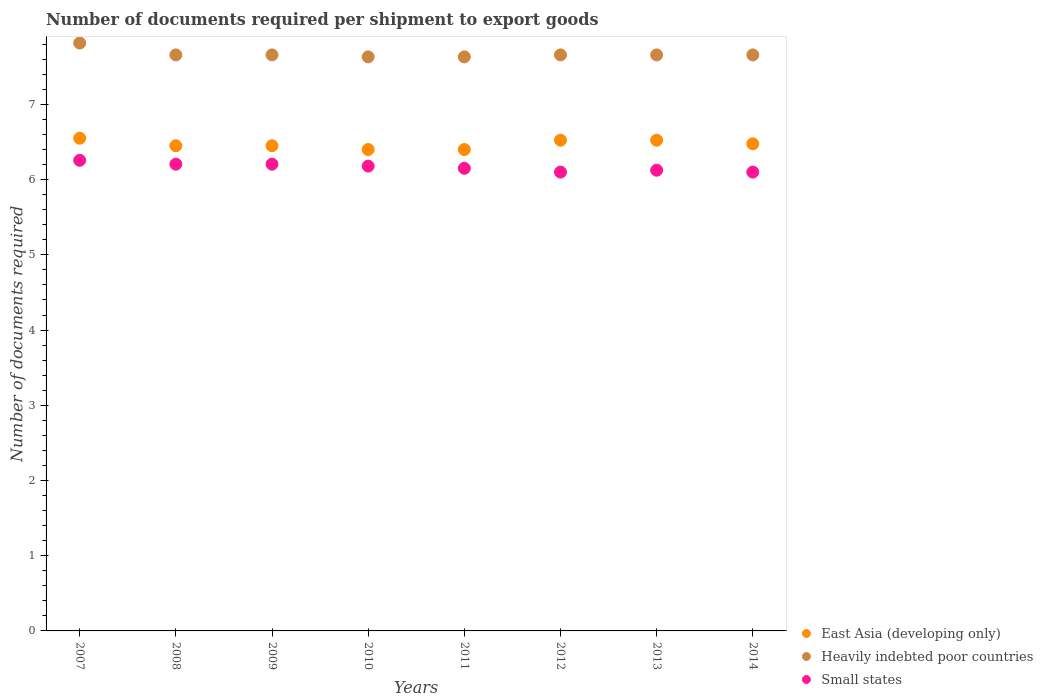What is the number of documents required per shipment to export goods in Heavily indebted poor countries in 2013?
Ensure brevity in your answer.  7.66. Across all years, what is the maximum number of documents required per shipment to export goods in Heavily indebted poor countries?
Ensure brevity in your answer.  7.82. Across all years, what is the minimum number of documents required per shipment to export goods in Small states?
Keep it short and to the point. 6.1. In which year was the number of documents required per shipment to export goods in Heavily indebted poor countries maximum?
Ensure brevity in your answer.  2007. What is the total number of documents required per shipment to export goods in Small states in the graph?
Provide a succinct answer. 49.32. What is the difference between the number of documents required per shipment to export goods in East Asia (developing only) in 2007 and that in 2009?
Give a very brief answer. 0.1. What is the difference between the number of documents required per shipment to export goods in Small states in 2011 and the number of documents required per shipment to export goods in Heavily indebted poor countries in 2014?
Keep it short and to the point. -1.51. What is the average number of documents required per shipment to export goods in Heavily indebted poor countries per year?
Give a very brief answer. 7.67. In the year 2014, what is the difference between the number of documents required per shipment to export goods in Small states and number of documents required per shipment to export goods in East Asia (developing only)?
Make the answer very short. -0.38. What is the ratio of the number of documents required per shipment to export goods in East Asia (developing only) in 2010 to that in 2012?
Give a very brief answer. 0.98. Is the number of documents required per shipment to export goods in Small states in 2007 less than that in 2009?
Provide a succinct answer. No. Is the difference between the number of documents required per shipment to export goods in Small states in 2007 and 2013 greater than the difference between the number of documents required per shipment to export goods in East Asia (developing only) in 2007 and 2013?
Offer a terse response. Yes. What is the difference between the highest and the second highest number of documents required per shipment to export goods in Small states?
Provide a succinct answer. 0.05. What is the difference between the highest and the lowest number of documents required per shipment to export goods in Heavily indebted poor countries?
Give a very brief answer. 0.18. In how many years, is the number of documents required per shipment to export goods in East Asia (developing only) greater than the average number of documents required per shipment to export goods in East Asia (developing only) taken over all years?
Offer a very short reply. 4. Is it the case that in every year, the sum of the number of documents required per shipment to export goods in Small states and number of documents required per shipment to export goods in East Asia (developing only)  is greater than the number of documents required per shipment to export goods in Heavily indebted poor countries?
Provide a succinct answer. Yes. Is the number of documents required per shipment to export goods in Small states strictly greater than the number of documents required per shipment to export goods in East Asia (developing only) over the years?
Provide a succinct answer. No. Is the number of documents required per shipment to export goods in Heavily indebted poor countries strictly less than the number of documents required per shipment to export goods in Small states over the years?
Offer a very short reply. No. Are the values on the major ticks of Y-axis written in scientific E-notation?
Offer a terse response. No. Does the graph contain grids?
Make the answer very short. No. Where does the legend appear in the graph?
Provide a short and direct response. Bottom right. How many legend labels are there?
Your response must be concise. 3. How are the legend labels stacked?
Your response must be concise. Vertical. What is the title of the graph?
Your answer should be very brief. Number of documents required per shipment to export goods. What is the label or title of the Y-axis?
Make the answer very short. Number of documents required. What is the Number of documents required in East Asia (developing only) in 2007?
Provide a succinct answer. 6.55. What is the Number of documents required in Heavily indebted poor countries in 2007?
Your answer should be very brief. 7.82. What is the Number of documents required of Small states in 2007?
Your response must be concise. 6.26. What is the Number of documents required of East Asia (developing only) in 2008?
Offer a very short reply. 6.45. What is the Number of documents required of Heavily indebted poor countries in 2008?
Offer a very short reply. 7.66. What is the Number of documents required of Small states in 2008?
Offer a terse response. 6.21. What is the Number of documents required in East Asia (developing only) in 2009?
Provide a succinct answer. 6.45. What is the Number of documents required of Heavily indebted poor countries in 2009?
Keep it short and to the point. 7.66. What is the Number of documents required in Small states in 2009?
Give a very brief answer. 6.21. What is the Number of documents required of Heavily indebted poor countries in 2010?
Your answer should be very brief. 7.63. What is the Number of documents required in Small states in 2010?
Ensure brevity in your answer.  6.18. What is the Number of documents required in East Asia (developing only) in 2011?
Offer a terse response. 6.4. What is the Number of documents required of Heavily indebted poor countries in 2011?
Provide a succinct answer. 7.63. What is the Number of documents required in Small states in 2011?
Ensure brevity in your answer.  6.15. What is the Number of documents required in East Asia (developing only) in 2012?
Your answer should be very brief. 6.52. What is the Number of documents required of Heavily indebted poor countries in 2012?
Ensure brevity in your answer.  7.66. What is the Number of documents required in East Asia (developing only) in 2013?
Provide a succinct answer. 6.52. What is the Number of documents required of Heavily indebted poor countries in 2013?
Give a very brief answer. 7.66. What is the Number of documents required in Small states in 2013?
Your response must be concise. 6.12. What is the Number of documents required in East Asia (developing only) in 2014?
Give a very brief answer. 6.48. What is the Number of documents required in Heavily indebted poor countries in 2014?
Offer a very short reply. 7.66. What is the Number of documents required in Small states in 2014?
Give a very brief answer. 6.1. Across all years, what is the maximum Number of documents required of East Asia (developing only)?
Make the answer very short. 6.55. Across all years, what is the maximum Number of documents required in Heavily indebted poor countries?
Make the answer very short. 7.82. Across all years, what is the maximum Number of documents required of Small states?
Ensure brevity in your answer.  6.26. Across all years, what is the minimum Number of documents required of East Asia (developing only)?
Give a very brief answer. 6.4. Across all years, what is the minimum Number of documents required of Heavily indebted poor countries?
Give a very brief answer. 7.63. Across all years, what is the minimum Number of documents required of Small states?
Offer a very short reply. 6.1. What is the total Number of documents required of East Asia (developing only) in the graph?
Your response must be concise. 51.77. What is the total Number of documents required in Heavily indebted poor countries in the graph?
Your response must be concise. 61.37. What is the total Number of documents required of Small states in the graph?
Your answer should be compact. 49.32. What is the difference between the Number of documents required of East Asia (developing only) in 2007 and that in 2008?
Offer a terse response. 0.1. What is the difference between the Number of documents required in Heavily indebted poor countries in 2007 and that in 2008?
Your answer should be compact. 0.16. What is the difference between the Number of documents required in Small states in 2007 and that in 2008?
Offer a terse response. 0.05. What is the difference between the Number of documents required of East Asia (developing only) in 2007 and that in 2009?
Give a very brief answer. 0.1. What is the difference between the Number of documents required in Heavily indebted poor countries in 2007 and that in 2009?
Your answer should be compact. 0.16. What is the difference between the Number of documents required of Small states in 2007 and that in 2009?
Your answer should be very brief. 0.05. What is the difference between the Number of documents required of East Asia (developing only) in 2007 and that in 2010?
Your answer should be very brief. 0.15. What is the difference between the Number of documents required of Heavily indebted poor countries in 2007 and that in 2010?
Make the answer very short. 0.18. What is the difference between the Number of documents required of Small states in 2007 and that in 2010?
Give a very brief answer. 0.08. What is the difference between the Number of documents required of Heavily indebted poor countries in 2007 and that in 2011?
Offer a terse response. 0.18. What is the difference between the Number of documents required in Small states in 2007 and that in 2011?
Your answer should be very brief. 0.11. What is the difference between the Number of documents required in East Asia (developing only) in 2007 and that in 2012?
Offer a very short reply. 0.03. What is the difference between the Number of documents required in Heavily indebted poor countries in 2007 and that in 2012?
Offer a very short reply. 0.16. What is the difference between the Number of documents required of Small states in 2007 and that in 2012?
Give a very brief answer. 0.16. What is the difference between the Number of documents required in East Asia (developing only) in 2007 and that in 2013?
Provide a short and direct response. 0.03. What is the difference between the Number of documents required in Heavily indebted poor countries in 2007 and that in 2013?
Offer a very short reply. 0.16. What is the difference between the Number of documents required of Small states in 2007 and that in 2013?
Make the answer very short. 0.13. What is the difference between the Number of documents required in East Asia (developing only) in 2007 and that in 2014?
Your response must be concise. 0.07. What is the difference between the Number of documents required in Heavily indebted poor countries in 2007 and that in 2014?
Offer a very short reply. 0.16. What is the difference between the Number of documents required of Small states in 2007 and that in 2014?
Provide a short and direct response. 0.16. What is the difference between the Number of documents required in East Asia (developing only) in 2008 and that in 2009?
Your answer should be compact. 0. What is the difference between the Number of documents required in Heavily indebted poor countries in 2008 and that in 2010?
Your answer should be compact. 0.03. What is the difference between the Number of documents required of Small states in 2008 and that in 2010?
Provide a succinct answer. 0.03. What is the difference between the Number of documents required in East Asia (developing only) in 2008 and that in 2011?
Give a very brief answer. 0.05. What is the difference between the Number of documents required of Heavily indebted poor countries in 2008 and that in 2011?
Your answer should be very brief. 0.03. What is the difference between the Number of documents required of Small states in 2008 and that in 2011?
Provide a short and direct response. 0.06. What is the difference between the Number of documents required in East Asia (developing only) in 2008 and that in 2012?
Provide a short and direct response. -0.07. What is the difference between the Number of documents required in Heavily indebted poor countries in 2008 and that in 2012?
Give a very brief answer. 0. What is the difference between the Number of documents required of Small states in 2008 and that in 2012?
Provide a short and direct response. 0.11. What is the difference between the Number of documents required in East Asia (developing only) in 2008 and that in 2013?
Provide a short and direct response. -0.07. What is the difference between the Number of documents required of Heavily indebted poor countries in 2008 and that in 2013?
Your answer should be very brief. 0. What is the difference between the Number of documents required of Small states in 2008 and that in 2013?
Your response must be concise. 0.08. What is the difference between the Number of documents required of East Asia (developing only) in 2008 and that in 2014?
Provide a short and direct response. -0.03. What is the difference between the Number of documents required of Small states in 2008 and that in 2014?
Your answer should be compact. 0.11. What is the difference between the Number of documents required of Heavily indebted poor countries in 2009 and that in 2010?
Give a very brief answer. 0.03. What is the difference between the Number of documents required of Small states in 2009 and that in 2010?
Your answer should be compact. 0.03. What is the difference between the Number of documents required of Heavily indebted poor countries in 2009 and that in 2011?
Give a very brief answer. 0.03. What is the difference between the Number of documents required in Small states in 2009 and that in 2011?
Keep it short and to the point. 0.06. What is the difference between the Number of documents required in East Asia (developing only) in 2009 and that in 2012?
Your answer should be very brief. -0.07. What is the difference between the Number of documents required in Small states in 2009 and that in 2012?
Your answer should be compact. 0.11. What is the difference between the Number of documents required of East Asia (developing only) in 2009 and that in 2013?
Your response must be concise. -0.07. What is the difference between the Number of documents required in Small states in 2009 and that in 2013?
Make the answer very short. 0.08. What is the difference between the Number of documents required in East Asia (developing only) in 2009 and that in 2014?
Your answer should be very brief. -0.03. What is the difference between the Number of documents required of Heavily indebted poor countries in 2009 and that in 2014?
Keep it short and to the point. 0. What is the difference between the Number of documents required in Small states in 2009 and that in 2014?
Provide a succinct answer. 0.11. What is the difference between the Number of documents required of Heavily indebted poor countries in 2010 and that in 2011?
Your response must be concise. 0. What is the difference between the Number of documents required in Small states in 2010 and that in 2011?
Your response must be concise. 0.03. What is the difference between the Number of documents required in East Asia (developing only) in 2010 and that in 2012?
Make the answer very short. -0.12. What is the difference between the Number of documents required of Heavily indebted poor countries in 2010 and that in 2012?
Offer a very short reply. -0.03. What is the difference between the Number of documents required in Small states in 2010 and that in 2012?
Your answer should be compact. 0.08. What is the difference between the Number of documents required of East Asia (developing only) in 2010 and that in 2013?
Give a very brief answer. -0.12. What is the difference between the Number of documents required in Heavily indebted poor countries in 2010 and that in 2013?
Ensure brevity in your answer.  -0.03. What is the difference between the Number of documents required in Small states in 2010 and that in 2013?
Keep it short and to the point. 0.05. What is the difference between the Number of documents required of East Asia (developing only) in 2010 and that in 2014?
Offer a very short reply. -0.08. What is the difference between the Number of documents required in Heavily indebted poor countries in 2010 and that in 2014?
Keep it short and to the point. -0.03. What is the difference between the Number of documents required of Small states in 2010 and that in 2014?
Provide a succinct answer. 0.08. What is the difference between the Number of documents required in East Asia (developing only) in 2011 and that in 2012?
Keep it short and to the point. -0.12. What is the difference between the Number of documents required of Heavily indebted poor countries in 2011 and that in 2012?
Make the answer very short. -0.03. What is the difference between the Number of documents required of East Asia (developing only) in 2011 and that in 2013?
Your answer should be compact. -0.12. What is the difference between the Number of documents required of Heavily indebted poor countries in 2011 and that in 2013?
Your answer should be very brief. -0.03. What is the difference between the Number of documents required in Small states in 2011 and that in 2013?
Your answer should be very brief. 0.03. What is the difference between the Number of documents required in East Asia (developing only) in 2011 and that in 2014?
Keep it short and to the point. -0.08. What is the difference between the Number of documents required of Heavily indebted poor countries in 2011 and that in 2014?
Offer a very short reply. -0.03. What is the difference between the Number of documents required of East Asia (developing only) in 2012 and that in 2013?
Your answer should be compact. 0. What is the difference between the Number of documents required of Heavily indebted poor countries in 2012 and that in 2013?
Your response must be concise. 0. What is the difference between the Number of documents required of Small states in 2012 and that in 2013?
Offer a terse response. -0.03. What is the difference between the Number of documents required in East Asia (developing only) in 2012 and that in 2014?
Ensure brevity in your answer.  0.05. What is the difference between the Number of documents required in Small states in 2012 and that in 2014?
Provide a succinct answer. 0. What is the difference between the Number of documents required of East Asia (developing only) in 2013 and that in 2014?
Ensure brevity in your answer.  0.05. What is the difference between the Number of documents required of Heavily indebted poor countries in 2013 and that in 2014?
Your answer should be very brief. 0. What is the difference between the Number of documents required in Small states in 2013 and that in 2014?
Your answer should be compact. 0.03. What is the difference between the Number of documents required in East Asia (developing only) in 2007 and the Number of documents required in Heavily indebted poor countries in 2008?
Make the answer very short. -1.11. What is the difference between the Number of documents required in East Asia (developing only) in 2007 and the Number of documents required in Small states in 2008?
Offer a very short reply. 0.34. What is the difference between the Number of documents required in Heavily indebted poor countries in 2007 and the Number of documents required in Small states in 2008?
Your answer should be very brief. 1.61. What is the difference between the Number of documents required of East Asia (developing only) in 2007 and the Number of documents required of Heavily indebted poor countries in 2009?
Offer a very short reply. -1.11. What is the difference between the Number of documents required in East Asia (developing only) in 2007 and the Number of documents required in Small states in 2009?
Ensure brevity in your answer.  0.34. What is the difference between the Number of documents required in Heavily indebted poor countries in 2007 and the Number of documents required in Small states in 2009?
Offer a very short reply. 1.61. What is the difference between the Number of documents required in East Asia (developing only) in 2007 and the Number of documents required in Heavily indebted poor countries in 2010?
Provide a short and direct response. -1.08. What is the difference between the Number of documents required of East Asia (developing only) in 2007 and the Number of documents required of Small states in 2010?
Keep it short and to the point. 0.37. What is the difference between the Number of documents required of Heavily indebted poor countries in 2007 and the Number of documents required of Small states in 2010?
Your answer should be compact. 1.64. What is the difference between the Number of documents required of East Asia (developing only) in 2007 and the Number of documents required of Heavily indebted poor countries in 2011?
Your response must be concise. -1.08. What is the difference between the Number of documents required of Heavily indebted poor countries in 2007 and the Number of documents required of Small states in 2011?
Make the answer very short. 1.67. What is the difference between the Number of documents required in East Asia (developing only) in 2007 and the Number of documents required in Heavily indebted poor countries in 2012?
Your answer should be very brief. -1.11. What is the difference between the Number of documents required in East Asia (developing only) in 2007 and the Number of documents required in Small states in 2012?
Ensure brevity in your answer.  0.45. What is the difference between the Number of documents required of Heavily indebted poor countries in 2007 and the Number of documents required of Small states in 2012?
Your response must be concise. 1.72. What is the difference between the Number of documents required of East Asia (developing only) in 2007 and the Number of documents required of Heavily indebted poor countries in 2013?
Ensure brevity in your answer.  -1.11. What is the difference between the Number of documents required in East Asia (developing only) in 2007 and the Number of documents required in Small states in 2013?
Offer a very short reply. 0.42. What is the difference between the Number of documents required in Heavily indebted poor countries in 2007 and the Number of documents required in Small states in 2013?
Your response must be concise. 1.69. What is the difference between the Number of documents required in East Asia (developing only) in 2007 and the Number of documents required in Heavily indebted poor countries in 2014?
Offer a very short reply. -1.11. What is the difference between the Number of documents required in East Asia (developing only) in 2007 and the Number of documents required in Small states in 2014?
Provide a short and direct response. 0.45. What is the difference between the Number of documents required of Heavily indebted poor countries in 2007 and the Number of documents required of Small states in 2014?
Your response must be concise. 1.72. What is the difference between the Number of documents required in East Asia (developing only) in 2008 and the Number of documents required in Heavily indebted poor countries in 2009?
Your response must be concise. -1.21. What is the difference between the Number of documents required in East Asia (developing only) in 2008 and the Number of documents required in Small states in 2009?
Offer a very short reply. 0.24. What is the difference between the Number of documents required in Heavily indebted poor countries in 2008 and the Number of documents required in Small states in 2009?
Ensure brevity in your answer.  1.45. What is the difference between the Number of documents required in East Asia (developing only) in 2008 and the Number of documents required in Heavily indebted poor countries in 2010?
Offer a very short reply. -1.18. What is the difference between the Number of documents required of East Asia (developing only) in 2008 and the Number of documents required of Small states in 2010?
Offer a terse response. 0.27. What is the difference between the Number of documents required in Heavily indebted poor countries in 2008 and the Number of documents required in Small states in 2010?
Offer a very short reply. 1.48. What is the difference between the Number of documents required in East Asia (developing only) in 2008 and the Number of documents required in Heavily indebted poor countries in 2011?
Give a very brief answer. -1.18. What is the difference between the Number of documents required in East Asia (developing only) in 2008 and the Number of documents required in Small states in 2011?
Your answer should be compact. 0.3. What is the difference between the Number of documents required in Heavily indebted poor countries in 2008 and the Number of documents required in Small states in 2011?
Keep it short and to the point. 1.51. What is the difference between the Number of documents required in East Asia (developing only) in 2008 and the Number of documents required in Heavily indebted poor countries in 2012?
Offer a terse response. -1.21. What is the difference between the Number of documents required of Heavily indebted poor countries in 2008 and the Number of documents required of Small states in 2012?
Keep it short and to the point. 1.56. What is the difference between the Number of documents required of East Asia (developing only) in 2008 and the Number of documents required of Heavily indebted poor countries in 2013?
Give a very brief answer. -1.21. What is the difference between the Number of documents required of East Asia (developing only) in 2008 and the Number of documents required of Small states in 2013?
Your response must be concise. 0.33. What is the difference between the Number of documents required in Heavily indebted poor countries in 2008 and the Number of documents required in Small states in 2013?
Keep it short and to the point. 1.53. What is the difference between the Number of documents required in East Asia (developing only) in 2008 and the Number of documents required in Heavily indebted poor countries in 2014?
Offer a very short reply. -1.21. What is the difference between the Number of documents required of East Asia (developing only) in 2008 and the Number of documents required of Small states in 2014?
Offer a very short reply. 0.35. What is the difference between the Number of documents required in Heavily indebted poor countries in 2008 and the Number of documents required in Small states in 2014?
Your answer should be compact. 1.56. What is the difference between the Number of documents required in East Asia (developing only) in 2009 and the Number of documents required in Heavily indebted poor countries in 2010?
Keep it short and to the point. -1.18. What is the difference between the Number of documents required of East Asia (developing only) in 2009 and the Number of documents required of Small states in 2010?
Your response must be concise. 0.27. What is the difference between the Number of documents required of Heavily indebted poor countries in 2009 and the Number of documents required of Small states in 2010?
Offer a terse response. 1.48. What is the difference between the Number of documents required in East Asia (developing only) in 2009 and the Number of documents required in Heavily indebted poor countries in 2011?
Ensure brevity in your answer.  -1.18. What is the difference between the Number of documents required of Heavily indebted poor countries in 2009 and the Number of documents required of Small states in 2011?
Offer a terse response. 1.51. What is the difference between the Number of documents required in East Asia (developing only) in 2009 and the Number of documents required in Heavily indebted poor countries in 2012?
Keep it short and to the point. -1.21. What is the difference between the Number of documents required of East Asia (developing only) in 2009 and the Number of documents required of Small states in 2012?
Offer a very short reply. 0.35. What is the difference between the Number of documents required of Heavily indebted poor countries in 2009 and the Number of documents required of Small states in 2012?
Offer a terse response. 1.56. What is the difference between the Number of documents required in East Asia (developing only) in 2009 and the Number of documents required in Heavily indebted poor countries in 2013?
Ensure brevity in your answer.  -1.21. What is the difference between the Number of documents required of East Asia (developing only) in 2009 and the Number of documents required of Small states in 2013?
Offer a very short reply. 0.33. What is the difference between the Number of documents required in Heavily indebted poor countries in 2009 and the Number of documents required in Small states in 2013?
Give a very brief answer. 1.53. What is the difference between the Number of documents required of East Asia (developing only) in 2009 and the Number of documents required of Heavily indebted poor countries in 2014?
Offer a very short reply. -1.21. What is the difference between the Number of documents required of Heavily indebted poor countries in 2009 and the Number of documents required of Small states in 2014?
Your answer should be very brief. 1.56. What is the difference between the Number of documents required of East Asia (developing only) in 2010 and the Number of documents required of Heavily indebted poor countries in 2011?
Provide a succinct answer. -1.23. What is the difference between the Number of documents required of East Asia (developing only) in 2010 and the Number of documents required of Small states in 2011?
Your response must be concise. 0.25. What is the difference between the Number of documents required of Heavily indebted poor countries in 2010 and the Number of documents required of Small states in 2011?
Provide a succinct answer. 1.48. What is the difference between the Number of documents required of East Asia (developing only) in 2010 and the Number of documents required of Heavily indebted poor countries in 2012?
Your response must be concise. -1.26. What is the difference between the Number of documents required in Heavily indebted poor countries in 2010 and the Number of documents required in Small states in 2012?
Your response must be concise. 1.53. What is the difference between the Number of documents required in East Asia (developing only) in 2010 and the Number of documents required in Heavily indebted poor countries in 2013?
Provide a short and direct response. -1.26. What is the difference between the Number of documents required in East Asia (developing only) in 2010 and the Number of documents required in Small states in 2013?
Make the answer very short. 0.28. What is the difference between the Number of documents required of Heavily indebted poor countries in 2010 and the Number of documents required of Small states in 2013?
Your answer should be very brief. 1.51. What is the difference between the Number of documents required in East Asia (developing only) in 2010 and the Number of documents required in Heavily indebted poor countries in 2014?
Make the answer very short. -1.26. What is the difference between the Number of documents required of East Asia (developing only) in 2010 and the Number of documents required of Small states in 2014?
Make the answer very short. 0.3. What is the difference between the Number of documents required in Heavily indebted poor countries in 2010 and the Number of documents required in Small states in 2014?
Provide a short and direct response. 1.53. What is the difference between the Number of documents required of East Asia (developing only) in 2011 and the Number of documents required of Heavily indebted poor countries in 2012?
Give a very brief answer. -1.26. What is the difference between the Number of documents required in East Asia (developing only) in 2011 and the Number of documents required in Small states in 2012?
Your answer should be compact. 0.3. What is the difference between the Number of documents required of Heavily indebted poor countries in 2011 and the Number of documents required of Small states in 2012?
Offer a terse response. 1.53. What is the difference between the Number of documents required in East Asia (developing only) in 2011 and the Number of documents required in Heavily indebted poor countries in 2013?
Offer a very short reply. -1.26. What is the difference between the Number of documents required of East Asia (developing only) in 2011 and the Number of documents required of Small states in 2013?
Make the answer very short. 0.28. What is the difference between the Number of documents required of Heavily indebted poor countries in 2011 and the Number of documents required of Small states in 2013?
Offer a very short reply. 1.51. What is the difference between the Number of documents required of East Asia (developing only) in 2011 and the Number of documents required of Heavily indebted poor countries in 2014?
Give a very brief answer. -1.26. What is the difference between the Number of documents required in Heavily indebted poor countries in 2011 and the Number of documents required in Small states in 2014?
Your response must be concise. 1.53. What is the difference between the Number of documents required in East Asia (developing only) in 2012 and the Number of documents required in Heavily indebted poor countries in 2013?
Ensure brevity in your answer.  -1.13. What is the difference between the Number of documents required in East Asia (developing only) in 2012 and the Number of documents required in Small states in 2013?
Offer a terse response. 0.4. What is the difference between the Number of documents required of Heavily indebted poor countries in 2012 and the Number of documents required of Small states in 2013?
Ensure brevity in your answer.  1.53. What is the difference between the Number of documents required of East Asia (developing only) in 2012 and the Number of documents required of Heavily indebted poor countries in 2014?
Make the answer very short. -1.13. What is the difference between the Number of documents required in East Asia (developing only) in 2012 and the Number of documents required in Small states in 2014?
Offer a terse response. 0.42. What is the difference between the Number of documents required of Heavily indebted poor countries in 2012 and the Number of documents required of Small states in 2014?
Your answer should be compact. 1.56. What is the difference between the Number of documents required of East Asia (developing only) in 2013 and the Number of documents required of Heavily indebted poor countries in 2014?
Give a very brief answer. -1.13. What is the difference between the Number of documents required in East Asia (developing only) in 2013 and the Number of documents required in Small states in 2014?
Give a very brief answer. 0.42. What is the difference between the Number of documents required of Heavily indebted poor countries in 2013 and the Number of documents required of Small states in 2014?
Keep it short and to the point. 1.56. What is the average Number of documents required of East Asia (developing only) per year?
Make the answer very short. 6.47. What is the average Number of documents required in Heavily indebted poor countries per year?
Ensure brevity in your answer.  7.67. What is the average Number of documents required of Small states per year?
Provide a short and direct response. 6.17. In the year 2007, what is the difference between the Number of documents required of East Asia (developing only) and Number of documents required of Heavily indebted poor countries?
Give a very brief answer. -1.27. In the year 2007, what is the difference between the Number of documents required of East Asia (developing only) and Number of documents required of Small states?
Your answer should be compact. 0.29. In the year 2007, what is the difference between the Number of documents required in Heavily indebted poor countries and Number of documents required in Small states?
Give a very brief answer. 1.56. In the year 2008, what is the difference between the Number of documents required in East Asia (developing only) and Number of documents required in Heavily indebted poor countries?
Offer a terse response. -1.21. In the year 2008, what is the difference between the Number of documents required in East Asia (developing only) and Number of documents required in Small states?
Provide a succinct answer. 0.24. In the year 2008, what is the difference between the Number of documents required in Heavily indebted poor countries and Number of documents required in Small states?
Your answer should be compact. 1.45. In the year 2009, what is the difference between the Number of documents required in East Asia (developing only) and Number of documents required in Heavily indebted poor countries?
Your answer should be compact. -1.21. In the year 2009, what is the difference between the Number of documents required in East Asia (developing only) and Number of documents required in Small states?
Give a very brief answer. 0.24. In the year 2009, what is the difference between the Number of documents required in Heavily indebted poor countries and Number of documents required in Small states?
Offer a terse response. 1.45. In the year 2010, what is the difference between the Number of documents required in East Asia (developing only) and Number of documents required in Heavily indebted poor countries?
Your response must be concise. -1.23. In the year 2010, what is the difference between the Number of documents required in East Asia (developing only) and Number of documents required in Small states?
Your answer should be very brief. 0.22. In the year 2010, what is the difference between the Number of documents required in Heavily indebted poor countries and Number of documents required in Small states?
Offer a terse response. 1.45. In the year 2011, what is the difference between the Number of documents required in East Asia (developing only) and Number of documents required in Heavily indebted poor countries?
Your answer should be very brief. -1.23. In the year 2011, what is the difference between the Number of documents required in Heavily indebted poor countries and Number of documents required in Small states?
Offer a very short reply. 1.48. In the year 2012, what is the difference between the Number of documents required of East Asia (developing only) and Number of documents required of Heavily indebted poor countries?
Offer a terse response. -1.13. In the year 2012, what is the difference between the Number of documents required in East Asia (developing only) and Number of documents required in Small states?
Ensure brevity in your answer.  0.42. In the year 2012, what is the difference between the Number of documents required in Heavily indebted poor countries and Number of documents required in Small states?
Ensure brevity in your answer.  1.56. In the year 2013, what is the difference between the Number of documents required of East Asia (developing only) and Number of documents required of Heavily indebted poor countries?
Offer a terse response. -1.13. In the year 2013, what is the difference between the Number of documents required of East Asia (developing only) and Number of documents required of Small states?
Give a very brief answer. 0.4. In the year 2013, what is the difference between the Number of documents required of Heavily indebted poor countries and Number of documents required of Small states?
Offer a terse response. 1.53. In the year 2014, what is the difference between the Number of documents required of East Asia (developing only) and Number of documents required of Heavily indebted poor countries?
Make the answer very short. -1.18. In the year 2014, what is the difference between the Number of documents required of East Asia (developing only) and Number of documents required of Small states?
Provide a short and direct response. 0.38. In the year 2014, what is the difference between the Number of documents required of Heavily indebted poor countries and Number of documents required of Small states?
Your answer should be compact. 1.56. What is the ratio of the Number of documents required of East Asia (developing only) in 2007 to that in 2008?
Give a very brief answer. 1.02. What is the ratio of the Number of documents required of Heavily indebted poor countries in 2007 to that in 2008?
Your answer should be compact. 1.02. What is the ratio of the Number of documents required of Small states in 2007 to that in 2008?
Your answer should be very brief. 1.01. What is the ratio of the Number of documents required in East Asia (developing only) in 2007 to that in 2009?
Offer a terse response. 1.02. What is the ratio of the Number of documents required of Heavily indebted poor countries in 2007 to that in 2009?
Make the answer very short. 1.02. What is the ratio of the Number of documents required of Small states in 2007 to that in 2009?
Give a very brief answer. 1.01. What is the ratio of the Number of documents required in East Asia (developing only) in 2007 to that in 2010?
Give a very brief answer. 1.02. What is the ratio of the Number of documents required in Heavily indebted poor countries in 2007 to that in 2010?
Offer a terse response. 1.02. What is the ratio of the Number of documents required of Small states in 2007 to that in 2010?
Offer a very short reply. 1.01. What is the ratio of the Number of documents required of East Asia (developing only) in 2007 to that in 2011?
Give a very brief answer. 1.02. What is the ratio of the Number of documents required in Heavily indebted poor countries in 2007 to that in 2011?
Ensure brevity in your answer.  1.02. What is the ratio of the Number of documents required in Small states in 2007 to that in 2011?
Offer a very short reply. 1.02. What is the ratio of the Number of documents required in Heavily indebted poor countries in 2007 to that in 2012?
Provide a succinct answer. 1.02. What is the ratio of the Number of documents required in Small states in 2007 to that in 2012?
Offer a terse response. 1.03. What is the ratio of the Number of documents required in Heavily indebted poor countries in 2007 to that in 2013?
Your answer should be very brief. 1.02. What is the ratio of the Number of documents required of Small states in 2007 to that in 2013?
Provide a succinct answer. 1.02. What is the ratio of the Number of documents required of East Asia (developing only) in 2007 to that in 2014?
Give a very brief answer. 1.01. What is the ratio of the Number of documents required in Heavily indebted poor countries in 2007 to that in 2014?
Provide a short and direct response. 1.02. What is the ratio of the Number of documents required of Small states in 2007 to that in 2014?
Your answer should be compact. 1.03. What is the ratio of the Number of documents required in East Asia (developing only) in 2008 to that in 2009?
Offer a terse response. 1. What is the ratio of the Number of documents required of Small states in 2008 to that in 2009?
Provide a short and direct response. 1. What is the ratio of the Number of documents required of Heavily indebted poor countries in 2008 to that in 2010?
Ensure brevity in your answer.  1. What is the ratio of the Number of documents required of East Asia (developing only) in 2008 to that in 2011?
Provide a succinct answer. 1.01. What is the ratio of the Number of documents required in Small states in 2008 to that in 2011?
Offer a terse response. 1.01. What is the ratio of the Number of documents required in East Asia (developing only) in 2008 to that in 2012?
Your answer should be compact. 0.99. What is the ratio of the Number of documents required in Small states in 2008 to that in 2012?
Make the answer very short. 1.02. What is the ratio of the Number of documents required of East Asia (developing only) in 2008 to that in 2013?
Your response must be concise. 0.99. What is the ratio of the Number of documents required of Heavily indebted poor countries in 2008 to that in 2013?
Ensure brevity in your answer.  1. What is the ratio of the Number of documents required of Small states in 2008 to that in 2013?
Offer a terse response. 1.01. What is the ratio of the Number of documents required of East Asia (developing only) in 2008 to that in 2014?
Your response must be concise. 1. What is the ratio of the Number of documents required of Heavily indebted poor countries in 2008 to that in 2014?
Make the answer very short. 1. What is the ratio of the Number of documents required of Small states in 2008 to that in 2014?
Your answer should be very brief. 1.02. What is the ratio of the Number of documents required of East Asia (developing only) in 2009 to that in 2010?
Your answer should be compact. 1.01. What is the ratio of the Number of documents required in Heavily indebted poor countries in 2009 to that in 2010?
Make the answer very short. 1. What is the ratio of the Number of documents required in Small states in 2009 to that in 2010?
Make the answer very short. 1. What is the ratio of the Number of documents required in East Asia (developing only) in 2009 to that in 2011?
Ensure brevity in your answer.  1.01. What is the ratio of the Number of documents required of Heavily indebted poor countries in 2009 to that in 2011?
Your answer should be compact. 1. What is the ratio of the Number of documents required in Small states in 2009 to that in 2011?
Give a very brief answer. 1.01. What is the ratio of the Number of documents required in East Asia (developing only) in 2009 to that in 2012?
Your answer should be very brief. 0.99. What is the ratio of the Number of documents required of Heavily indebted poor countries in 2009 to that in 2012?
Your response must be concise. 1. What is the ratio of the Number of documents required of Small states in 2009 to that in 2012?
Keep it short and to the point. 1.02. What is the ratio of the Number of documents required in East Asia (developing only) in 2009 to that in 2013?
Ensure brevity in your answer.  0.99. What is the ratio of the Number of documents required in Heavily indebted poor countries in 2009 to that in 2013?
Make the answer very short. 1. What is the ratio of the Number of documents required of Small states in 2009 to that in 2013?
Provide a succinct answer. 1.01. What is the ratio of the Number of documents required in East Asia (developing only) in 2009 to that in 2014?
Your response must be concise. 1. What is the ratio of the Number of documents required in Heavily indebted poor countries in 2009 to that in 2014?
Keep it short and to the point. 1. What is the ratio of the Number of documents required in Small states in 2009 to that in 2014?
Your answer should be very brief. 1.02. What is the ratio of the Number of documents required in Heavily indebted poor countries in 2010 to that in 2011?
Provide a succinct answer. 1. What is the ratio of the Number of documents required of Small states in 2010 to that in 2011?
Give a very brief answer. 1. What is the ratio of the Number of documents required in Heavily indebted poor countries in 2010 to that in 2012?
Ensure brevity in your answer.  1. What is the ratio of the Number of documents required in Small states in 2010 to that in 2012?
Keep it short and to the point. 1.01. What is the ratio of the Number of documents required in East Asia (developing only) in 2010 to that in 2013?
Offer a terse response. 0.98. What is the ratio of the Number of documents required in Small states in 2010 to that in 2013?
Provide a succinct answer. 1.01. What is the ratio of the Number of documents required in East Asia (developing only) in 2011 to that in 2012?
Your response must be concise. 0.98. What is the ratio of the Number of documents required of Heavily indebted poor countries in 2011 to that in 2012?
Your answer should be very brief. 1. What is the ratio of the Number of documents required in Small states in 2011 to that in 2012?
Offer a very short reply. 1.01. What is the ratio of the Number of documents required in Small states in 2011 to that in 2013?
Ensure brevity in your answer.  1. What is the ratio of the Number of documents required of Heavily indebted poor countries in 2011 to that in 2014?
Ensure brevity in your answer.  1. What is the ratio of the Number of documents required of Small states in 2011 to that in 2014?
Keep it short and to the point. 1.01. What is the ratio of the Number of documents required of Heavily indebted poor countries in 2012 to that in 2013?
Keep it short and to the point. 1. What is the ratio of the Number of documents required in East Asia (developing only) in 2012 to that in 2014?
Provide a succinct answer. 1.01. What is the ratio of the Number of documents required of Heavily indebted poor countries in 2012 to that in 2014?
Make the answer very short. 1. What is the ratio of the Number of documents required in East Asia (developing only) in 2013 to that in 2014?
Provide a short and direct response. 1.01. What is the ratio of the Number of documents required in Small states in 2013 to that in 2014?
Give a very brief answer. 1. What is the difference between the highest and the second highest Number of documents required in East Asia (developing only)?
Keep it short and to the point. 0.03. What is the difference between the highest and the second highest Number of documents required in Heavily indebted poor countries?
Give a very brief answer. 0.16. What is the difference between the highest and the second highest Number of documents required of Small states?
Give a very brief answer. 0.05. What is the difference between the highest and the lowest Number of documents required in East Asia (developing only)?
Provide a succinct answer. 0.15. What is the difference between the highest and the lowest Number of documents required in Heavily indebted poor countries?
Your answer should be very brief. 0.18. What is the difference between the highest and the lowest Number of documents required of Small states?
Provide a succinct answer. 0.16. 